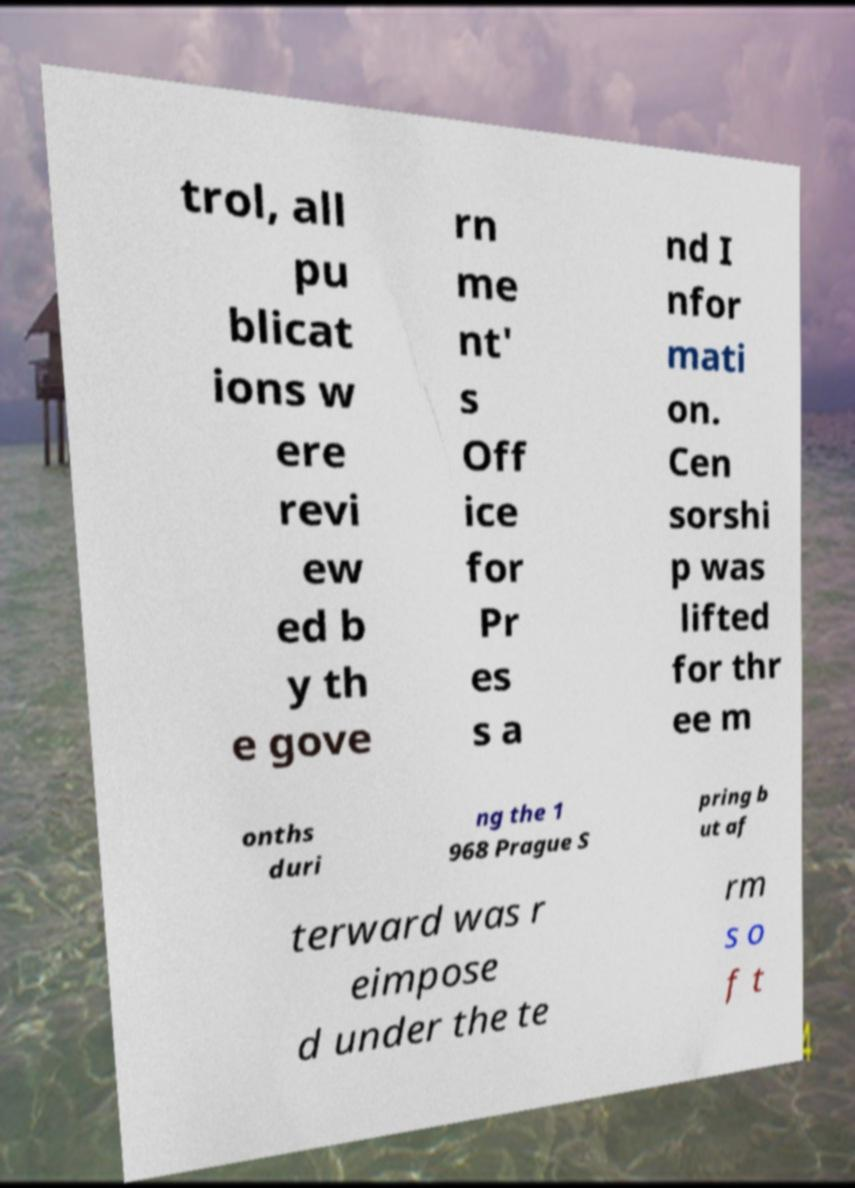Could you extract and type out the text from this image? trol, all pu blicat ions w ere revi ew ed b y th e gove rn me nt' s Off ice for Pr es s a nd I nfor mati on. Cen sorshi p was lifted for thr ee m onths duri ng the 1 968 Prague S pring b ut af terward was r eimpose d under the te rm s o f t 